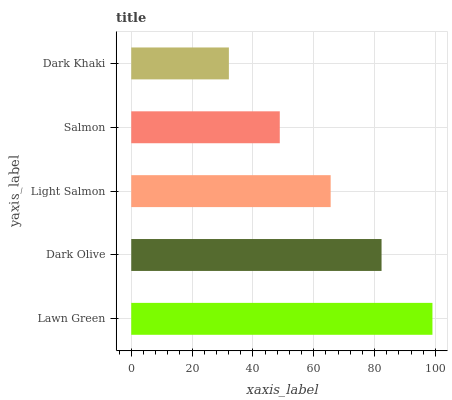Is Dark Khaki the minimum?
Answer yes or no. Yes. Is Lawn Green the maximum?
Answer yes or no. Yes. Is Dark Olive the minimum?
Answer yes or no. No. Is Dark Olive the maximum?
Answer yes or no. No. Is Lawn Green greater than Dark Olive?
Answer yes or no. Yes. Is Dark Olive less than Lawn Green?
Answer yes or no. Yes. Is Dark Olive greater than Lawn Green?
Answer yes or no. No. Is Lawn Green less than Dark Olive?
Answer yes or no. No. Is Light Salmon the high median?
Answer yes or no. Yes. Is Light Salmon the low median?
Answer yes or no. Yes. Is Salmon the high median?
Answer yes or no. No. Is Dark Olive the low median?
Answer yes or no. No. 